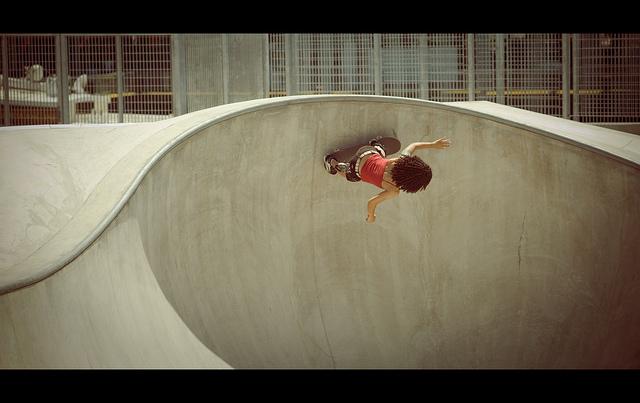Is the girl on motion?
Be succinct. Yes. What is the girl doing on the wall?
Concise answer only. Skateboarding. What is on the wall?
Be succinct. Skateboarder. 